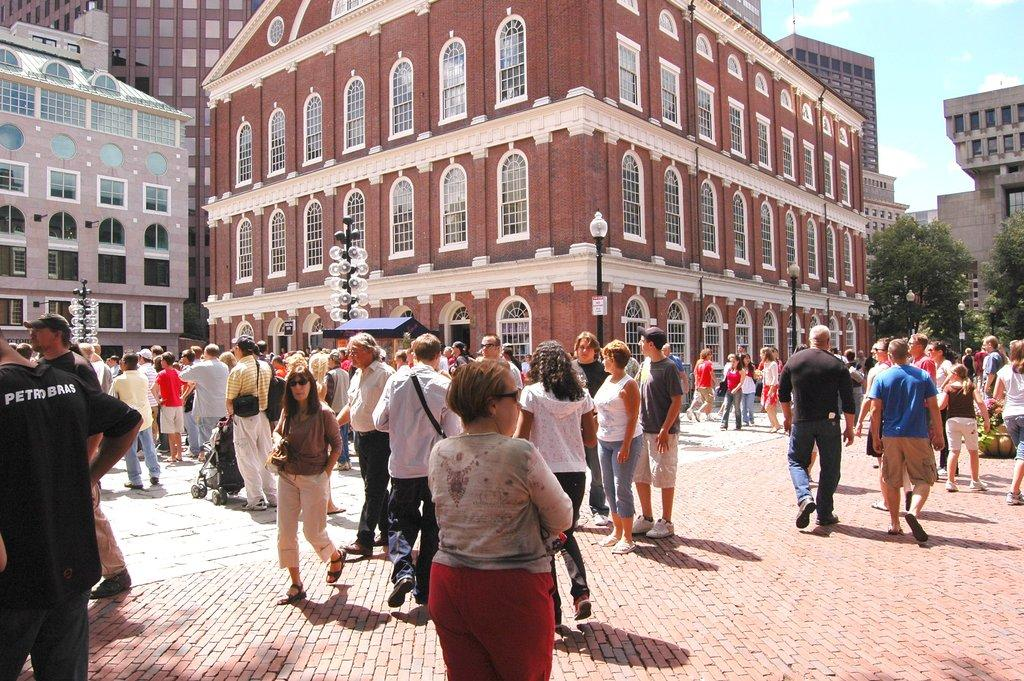Provide a one-sentence caption for the provided image. a courtyard in Europe with people including someone wearing a black PetroBras shirt. 